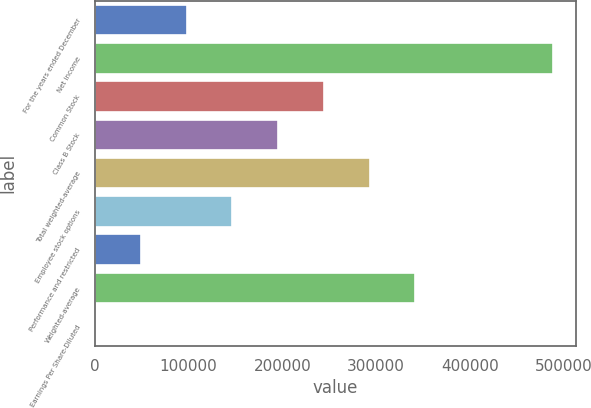Convert chart to OTSL. <chart><loc_0><loc_0><loc_500><loc_500><bar_chart><fcel>For the years ended December<fcel>Net income<fcel>Common Stock<fcel>Class B Stock<fcel>Total weighted-average<fcel>Employee stock options<fcel>Performance and restricted<fcel>Weighted-average<fcel>Earnings Per Share-Diluted<nl><fcel>97711<fcel>488547<fcel>244274<fcel>195420<fcel>293129<fcel>146565<fcel>48856.5<fcel>341983<fcel>1.97<nl></chart> 